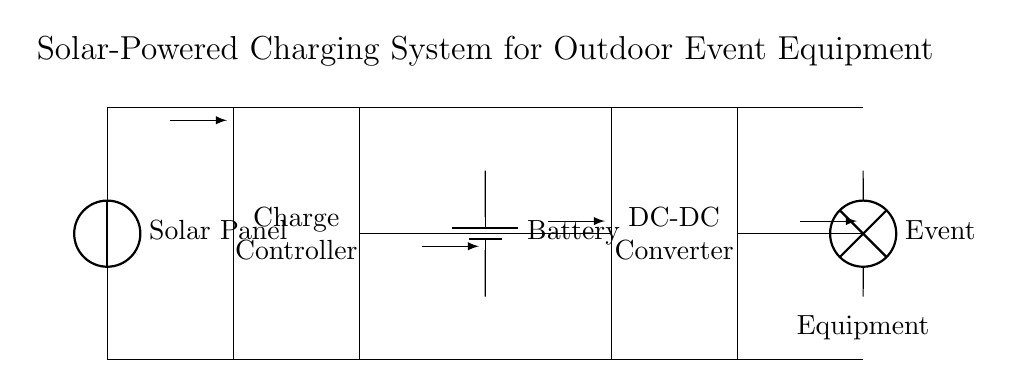What is the function of the solar panel in this circuit? The solar panel is responsible for converting sunlight into electrical energy, which powers the system. It is the starting point in the circuit that supplies energy.
Answer: convert sunlight to energy What component regulates the charging of the battery? The charge controller sits in the circuit between the solar panel and the battery. Its role is to manage the voltage and current going to the battery to prevent overcharging.
Answer: charge controller How many main components are visible in this circuit? By counting the distinct parts labeled in the circuit diagram, we see five: solar panel, charge controller, battery, DC-DC converter, and event equipment.
Answer: five What type of converter is used in this circuit? The circuit diagram indicates a DC-DC converter, which is used to adjust the voltage level of the DC output to match the requirements of the event equipment.
Answer: DC-DC converter What is the flow direction of the current from the solar panel? Tracing the arrows in the diagram, the current flows from the solar panel to the charge controller, indicating the charge direction.
Answer: from solar panel to charge controller Which component powers the event equipment? The event equipment is powered directly by the output from the DC-DC converter, indicating it provides the necessary power to operate.
Answer: DC-DC converter 